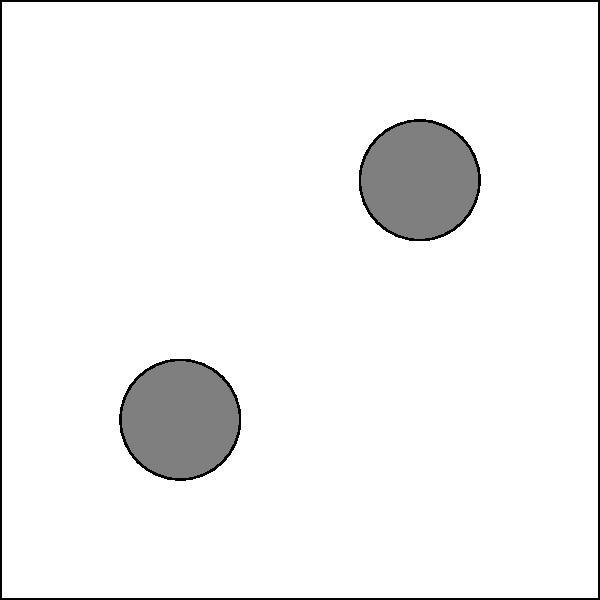In the given manufacturing facility layout, three optimal locations (A, B, and C) have been identified for placing IoT sensors to maximize coverage and data collection efficiency. Which placement strategy would you recommend to ensure comprehensive monitoring while minimizing the number of sensors used? To determine the best placement strategy for IoT sensors in this manufacturing facility, we need to consider several factors:

1. Coverage area: Each sensor should cover a significant portion of the facility without excessive overlap.

2. Proximity to equipment: Sensors should be placed near critical machinery to gather accurate data.

3. Minimizing the number of sensors: We want to achieve comprehensive coverage with the fewest sensors possible to reduce costs and complexity.

4. Central positioning: A centrally located sensor can provide a good overview of the entire facility.

Analyzing the given locations:

A (20,20): Located in the bottom-left quadrant, close to one piece of equipment.
B (80,80): Located in the top-right quadrant, close to another piece of equipment.
C (50,50): Centrally located, equidistant from all four pieces of equipment.

Step-by-step analysis:

1. If we choose only A or B, we would miss significant areas of the facility.
2. Choosing both A and B provides good coverage of opposite corners and monitoring of two equipment pieces, but might miss central activities.
3. Choosing C alone provides central coverage but might miss details near the corners.
4. The combination of A and B covers more area than A and C or B and C.
5. However, C's central location makes it valuable for overall monitoring.

Considering these factors, the optimal strategy would be to place sensors at locations B and C. This combination provides:

- Coverage of the top-right quadrant (B) and the center (C)
- Monitoring of equipment in the top-right and bottom-left (via C)
- A balance between corner and central monitoring
- Comprehensive coverage with just two sensors, optimizing cost-efficiency

While adding A would provide complete coverage, the goal is to minimize the number of sensors while ensuring comprehensive monitoring. The B and C combination achieves this balance effectively.
Answer: Place sensors at locations B and C 